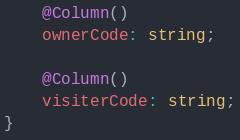Convert code to text. <code><loc_0><loc_0><loc_500><loc_500><_TypeScript_>
	@Column()
	ownerCode: string;

	@Column()
    visiterCode: string;
}</code> 